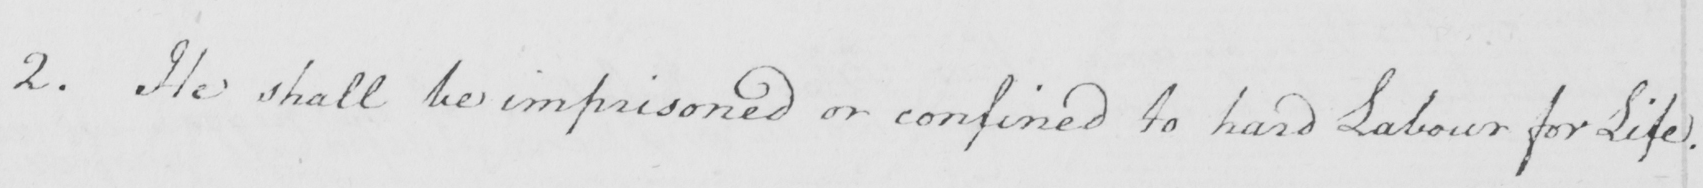Please transcribe the handwritten text in this image. 2 . He shall be imprisoned or confined to hard Labour for Life . 